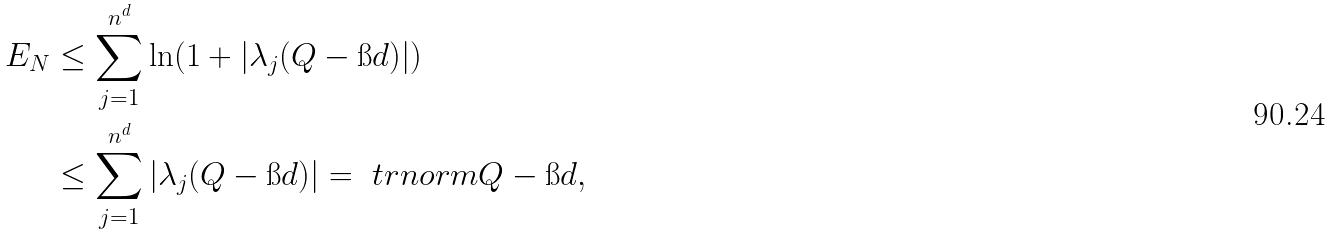Convert formula to latex. <formula><loc_0><loc_0><loc_500><loc_500>E _ { N } & \leq \sum _ { j = 1 } ^ { n ^ { d } } \ln ( 1 + | \lambda _ { j } ( Q - \i d ) | ) \\ & \leq \sum _ { j = 1 } ^ { n ^ { d } } | \lambda _ { j } ( Q - \i d ) | = \ t r n o r m { Q - \i d } ,</formula> 